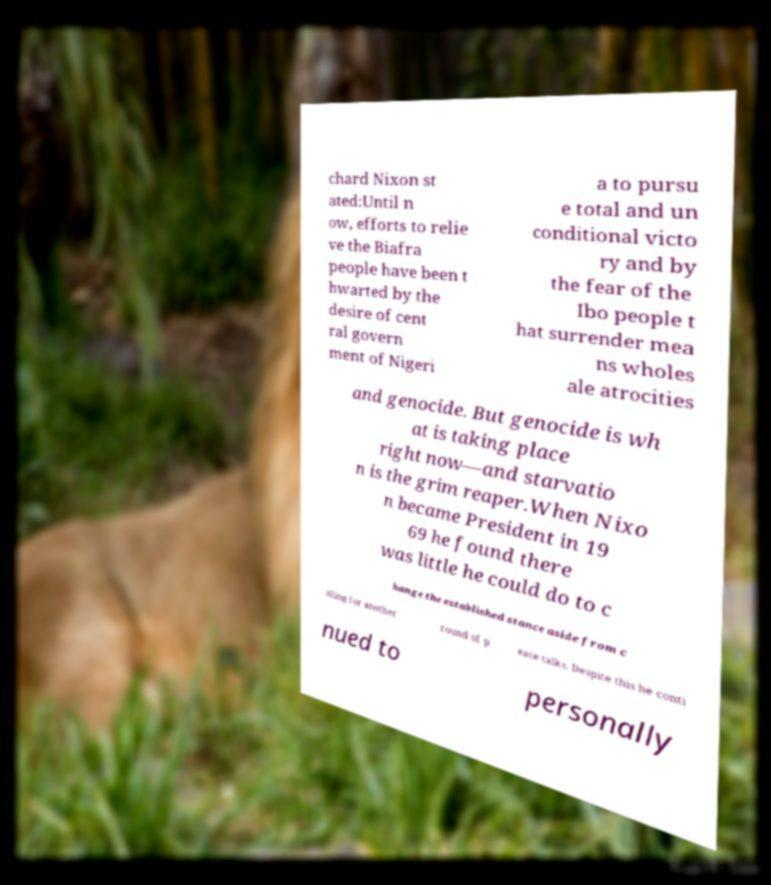Could you assist in decoding the text presented in this image and type it out clearly? chard Nixon st ated:Until n ow, efforts to relie ve the Biafra people have been t hwarted by the desire of cent ral govern ment of Nigeri a to pursu e total and un conditional victo ry and by the fear of the Ibo people t hat surrender mea ns wholes ale atrocities and genocide. But genocide is wh at is taking place right now—and starvatio n is the grim reaper.When Nixo n became President in 19 69 he found there was little he could do to c hange the established stance aside from c alling for another round of p eace talks. Despite this he conti nued to personally 